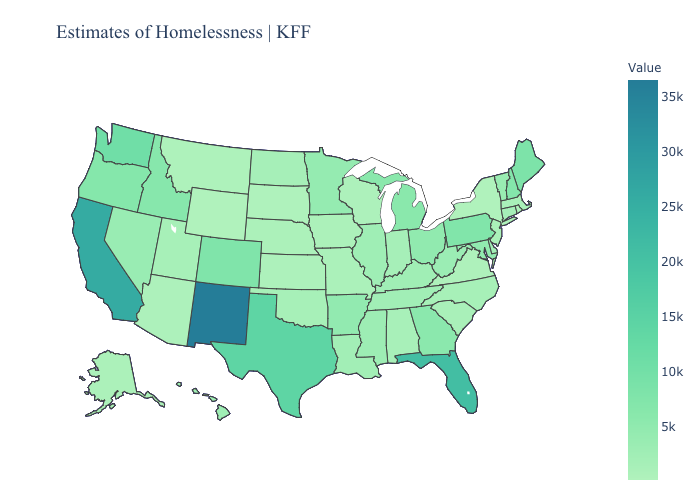Does the map have missing data?
Quick response, please. No. Among the states that border Oregon , does Idaho have the lowest value?
Quick response, please. No. Among the states that border Virginia , does North Carolina have the lowest value?
Write a very short answer. Yes. Does Georgia have a lower value than Wyoming?
Short answer required. No. Does Wyoming have the lowest value in the USA?
Answer briefly. Yes. Does the map have missing data?
Write a very short answer. No. Is the legend a continuous bar?
Answer briefly. Yes. 